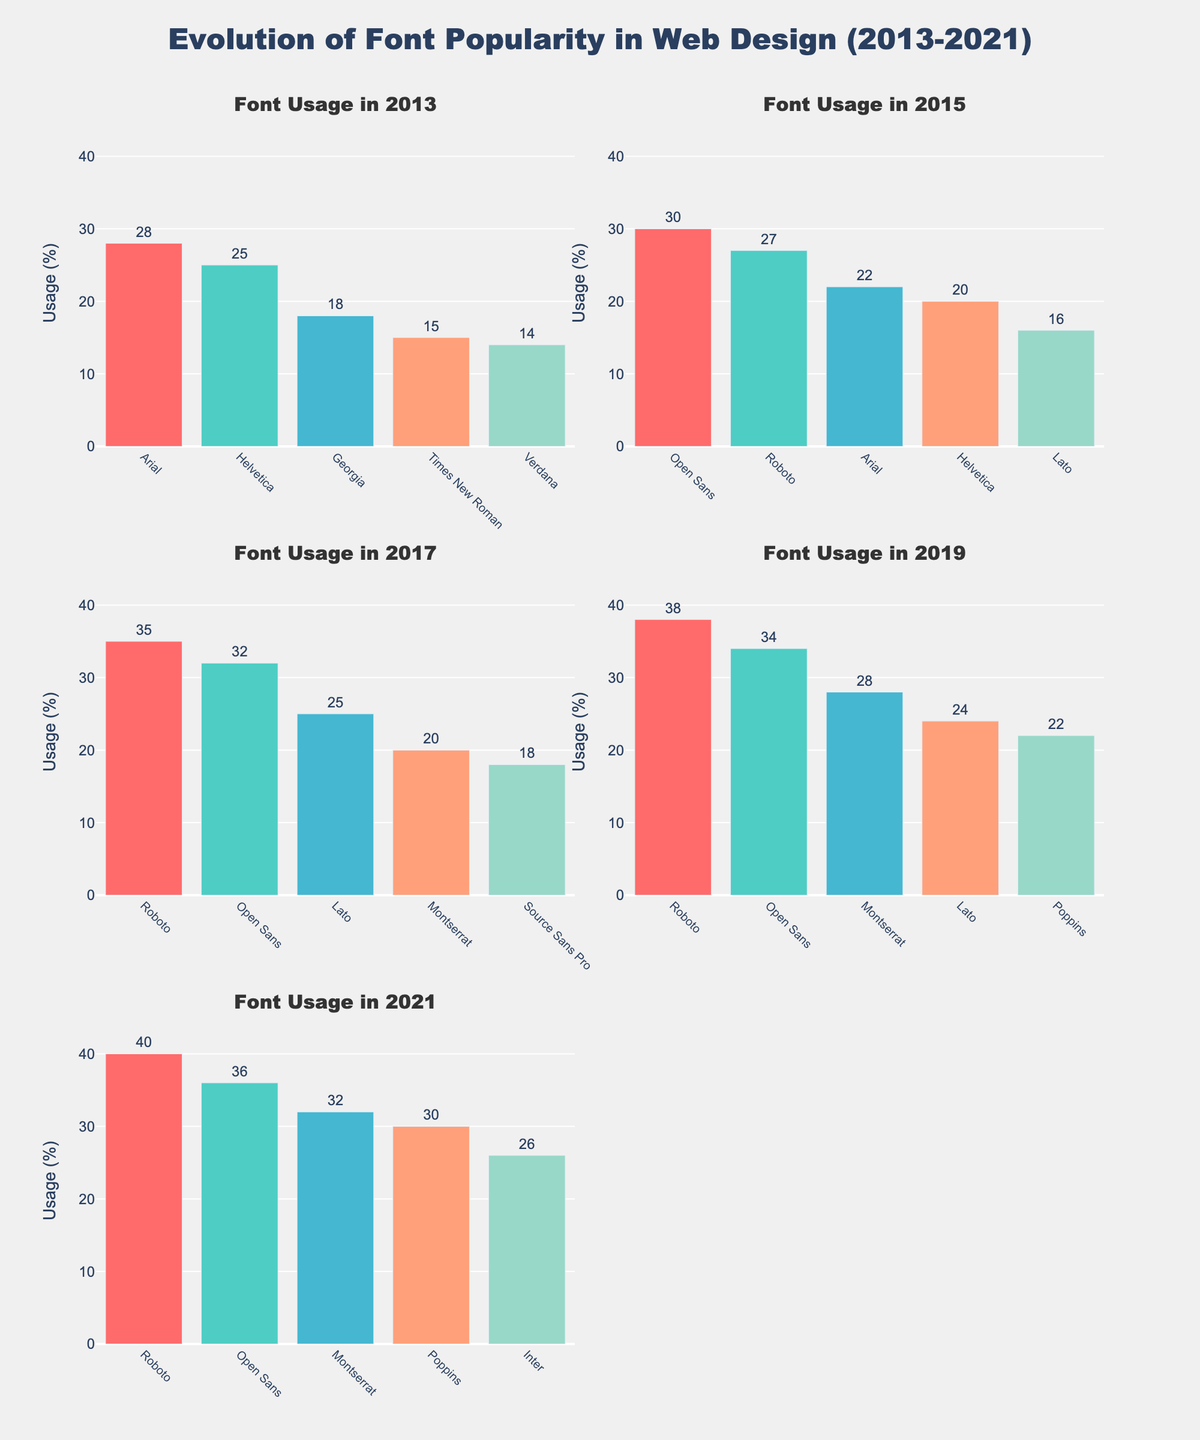What is the title of the figure? The title is located at the top center of the figure. It reads "Evolution of Font Popularity in Web Design (2013-2021)".
Answer: Evolution of Font Popularity in Web Design (2013-2021) How many total subplots are there in the figure? The figure contains six subplot titles, indicating there are six subplots, one for each year in the data: 2013, 2015, 2017, 2019, and 2021.
Answer: 6 Which font was most popular in 2019? In the subplot for 2019, the tallest bar corresponds to 'Roboto' with the highest usage percentage.
Answer: Roboto What was the usage of 'Open Sans' in 2015 and how does it compare to its usage in 2017? In the 2015 subplot, the usage of 'Open Sans' is 30%. In the 2017 subplot, the usage rises to 32%. So, the usage increased by 2 percentage points from 2015 to 2017.
Answer: 30%, increased by 2 percentage points Which year shows the highest usage for any single font, and what is that font and its usage percentage? The 2021 subplot shows 'Roboto' with a usage of 40%, which is the highest single font usage displayed in any year.
Answer: 2021, Roboto, 40% Among all the years shown, which font has appeared in all the subplots? 'Roboto' appears in each of the years' subplots: 2013, 2015, 2017, 2019, and 2021.
Answer: Roboto What was the total combined usage of the top three fonts in 2013? In 2013, the top three fonts are 'Arial' (28), 'Helvetica' (25), and 'Georgia' (18). Their combined usage is 28 + 25 + 18 = 71.
Answer: 71 In 2021, what is the difference in usage between 'Montserrat' and 'Inter'? In the 2021 subplot, 'Montserrat' has a usage of 32%, and 'Inter' has a usage of 26%. The difference is 32 - 26 = 6 percentage points.
Answer: 6 percentage points Which year's subplot shows the highest variety of fonts in use, and how many different fonts are shown? Counting the number of different fonts in each year's subplot: 2013 (5), 2015 (5), 2017 (5), 2019 (5), and 2021 (5). The variety is consistent across all years with five different fonts in each subplot.
Answer: All years, 5 fonts 